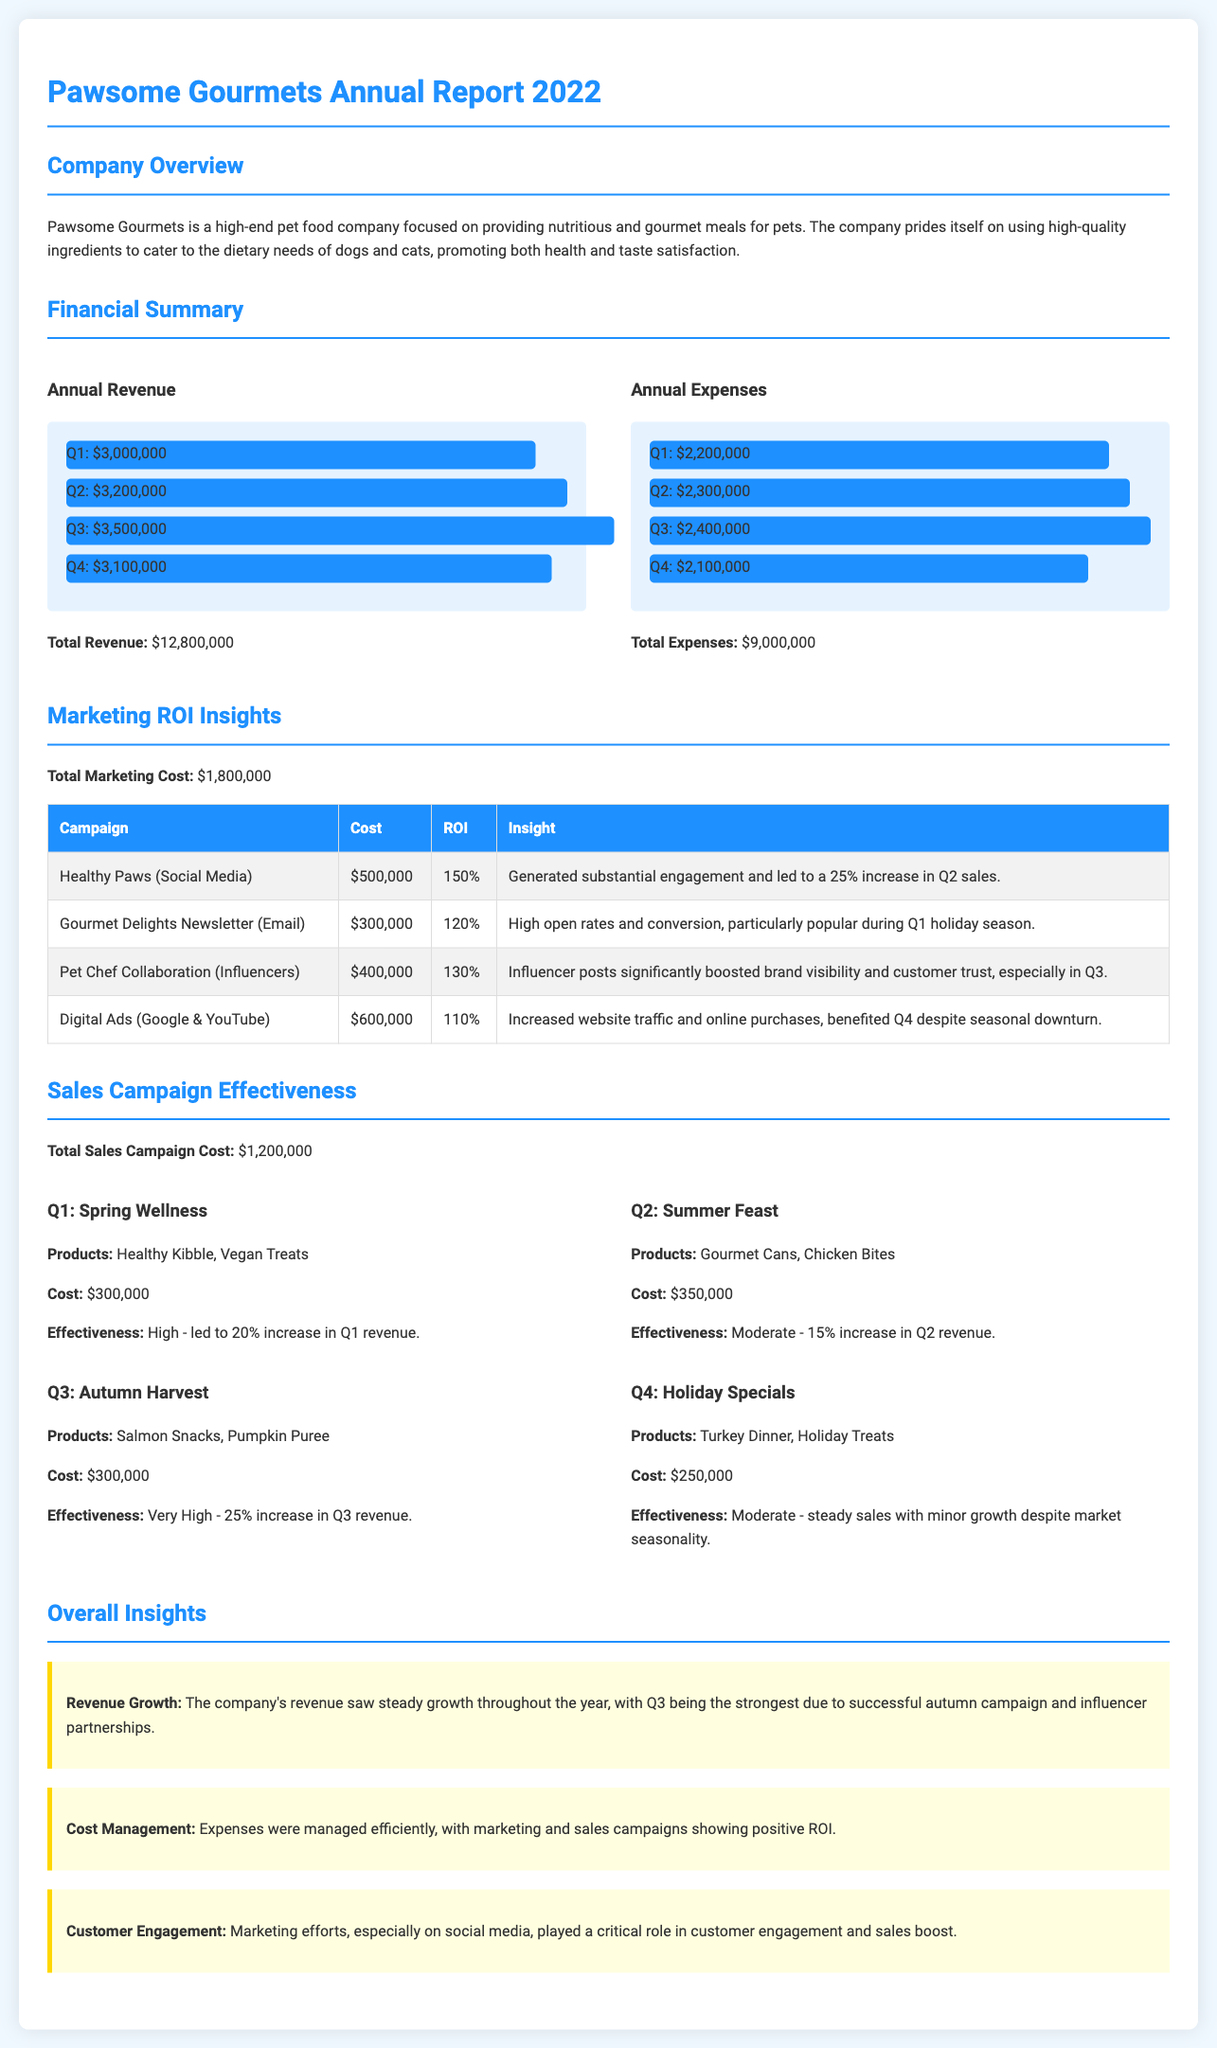What was the total annual revenue? The total annual revenue is calculated by adding the revenue from all four quarters, which totals $12,800,000.
Answer: $12,800,000 What was the highest quarterly revenue? The highest quarterly revenue was recorded in Q3, which is $3,500,000.
Answer: $3,500,000 What was the total marketing cost? The total marketing cost is explicitly stated as $1,800,000 in the marketing insights section.
Answer: $1,800,000 Which campaign had the highest ROI? Among the listed campaigns, the Healthy Paws (Social Media) had the highest ROI at 150%.
Answer: 150% What was the effectiveness of the Autumn Harvest campaign? The effectiveness of the Autumn Harvest campaign is categorized as very high, with a 25% increase in Q3 revenue.
Answer: Very High How much did the Q4 Holiday Specials campaign cost? The Q4 Holiday Specials campaign cost is mentioned as $250,000 in the sales campaign section.
Answer: $250,000 What was the total annual expense? The total annual expense is the sum of expenses from all quarters, totaling $9,000,000.
Answer: $9,000,000 What was the increase in revenue from the Spring Wellness campaign? The Spring Wellness campaign led to a 20% increase in Q1 revenue.
Answer: 20% Which marketing channel generated substantial engagement? The Healthy Paws (Social Media) campaign generated substantial engagement and a 25% increase in Q2 sales.
Answer: Healthy Paws (Social Media) 